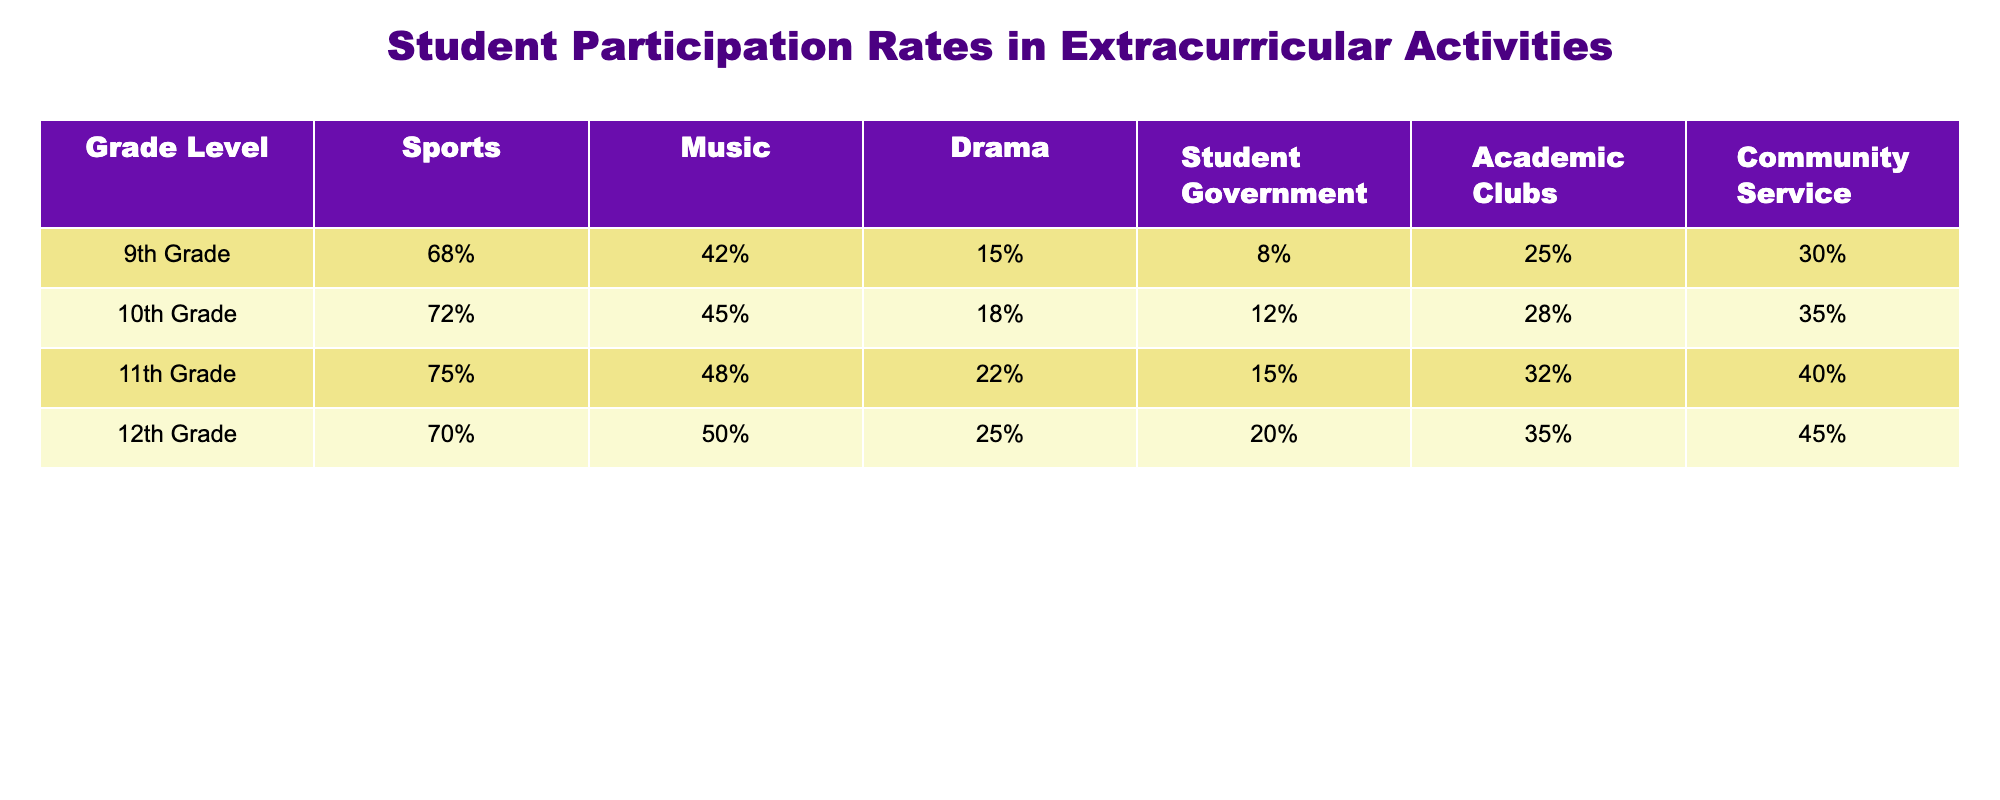What is the participation rate in sports for 10th graders? The table shows that the participation rate in sports for 10th graders is directly listed as 72%.
Answer: 72% In which activity do 11th graders have the highest participation rate? By reviewing the participation rates for all activities for 11th graders, drama has the highest participation rate at 22%.
Answer: Drama What is the average participation rate in music across all grade levels? To find the average participation rate in music, we sum the rates: (42% + 45% + 48% + 50%) = 185%. There are 4 grade levels, so the average is 185% / 4 = 46.25%.
Answer: 46.25% Do more 12th graders participate in sports or in academic clubs? The participation rate for sports among 12th graders is 70%, while academic clubs have 35%. Since 70% is greater than 35%, more 12th graders participate in sports.
Answer: Yes, more participate in sports What is the difference in participation rates for community service between 9th and 11th graders? The participation rate for community service among 9th graders is 30%, while for 11th graders it is 40%. The difference is calculated as 40% - 30% = 10%.
Answer: 10% Which grade level has the lowest participation rate in drama? The lowest participation rate for drama is found by comparing the rates for each grade: 15% for 9th graders is the lowest among all four grades.
Answer: 9th Grade If you were to compare the participation rates for student government across all grades, which is the largest? The rates for student government are 8% for 9th, 12% for 10th, 15% for 11th, and 20% for 12th grades. The largest is 20% for 12th graders.
Answer: 12th Grade How many students in 11th grade participate in music compared to 10th grade? The participation rate for music in 10th grade is 45%, while in 11th grade it is 48%. Comparing these, 48% is greater than 45%, which indicates more 11th graders participate in music than 10th graders.
Answer: Yes, more 11th graders participate What is the total participation rate in extracurricular activities for all students in 9th grade? To find the total participation rate in all activities for 9th graders, we add up all rates: 68% (sports) + 42% (music) + 15% (drama) + 8% (student government) + 25% (academic clubs) + 30% (community service) = 188%.
Answer: 188% Which extracurricular activity showed the smallest increase in participation rates from 10th to 11th grade? By comparing the activities: sports rise from 72% to 75% (+3%), music rises from 45% to 48% (+3%), drama rises from 18% to 22% (+4%), student government rises from 12% to 15% (+3%), academic clubs from 28% to 32% (+4%), and community service from 35% to 40% (+5%). The smallest increase is in sports, music, and student government with +3%.
Answer: Sports, Music, Student Government 